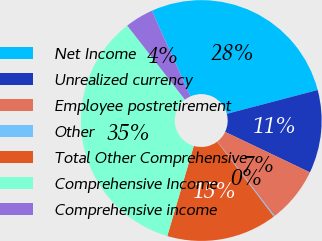Convert chart to OTSL. <chart><loc_0><loc_0><loc_500><loc_500><pie_chart><fcel>Net Income<fcel>Unrealized currency<fcel>Employee postretirement<fcel>Other<fcel>Total Other Comprehensive<fcel>Comprehensive Income<fcel>Comprehensive income<nl><fcel>27.64%<fcel>11.17%<fcel>7.49%<fcel>0.14%<fcel>14.84%<fcel>34.91%<fcel>3.82%<nl></chart> 